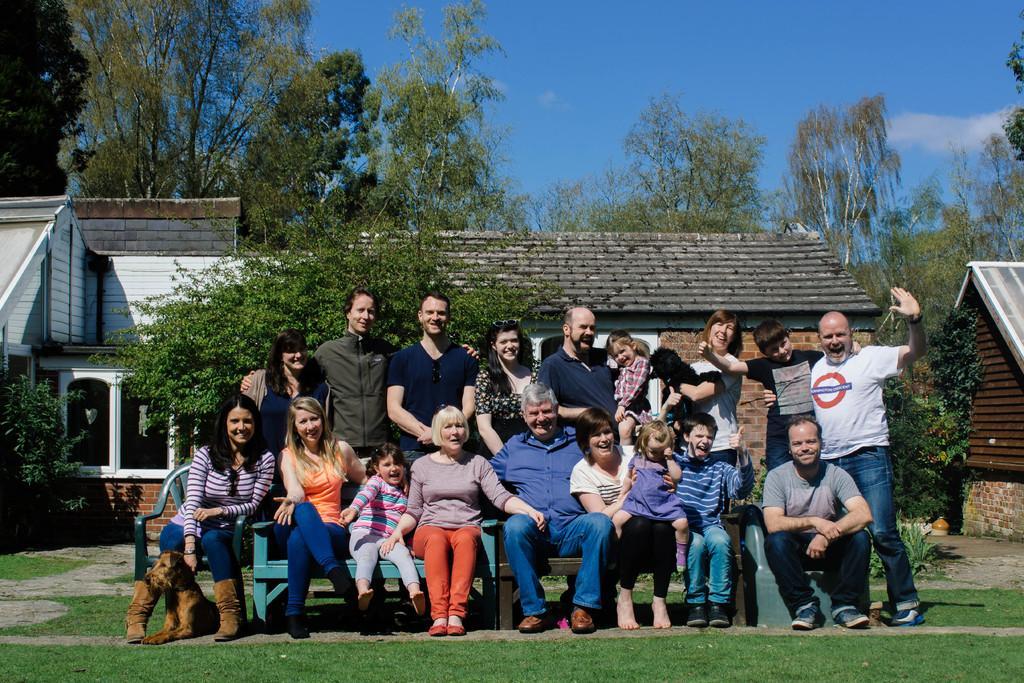Could you give a brief overview of what you see in this image? There are few people here sitting on the chair and behind them few are standing and all are giving pose to have a picture. In the background there are buildings,trees and a sky. 